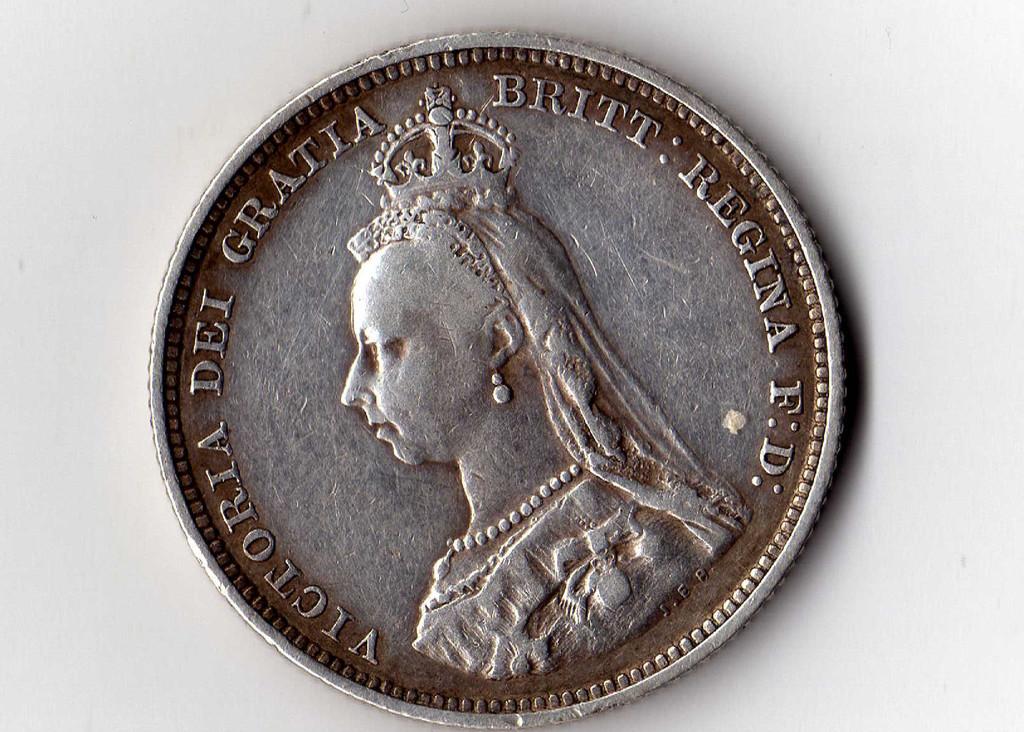Who is shown on this coin?
Your response must be concise. Victoria dei gratia. 